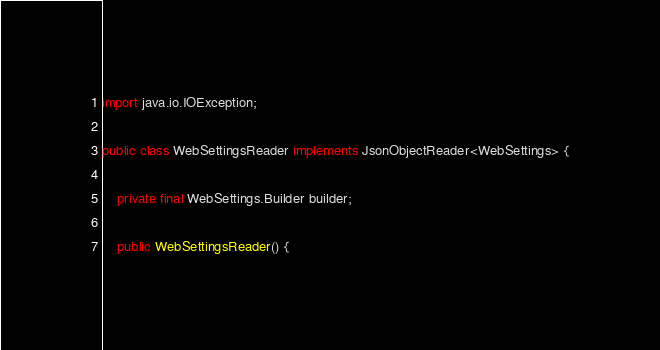<code> <loc_0><loc_0><loc_500><loc_500><_Java_>import java.io.IOException;

public class WebSettingsReader implements JsonObjectReader<WebSettings> {

    private final WebSettings.Builder builder;

    public WebSettingsReader() {</code> 